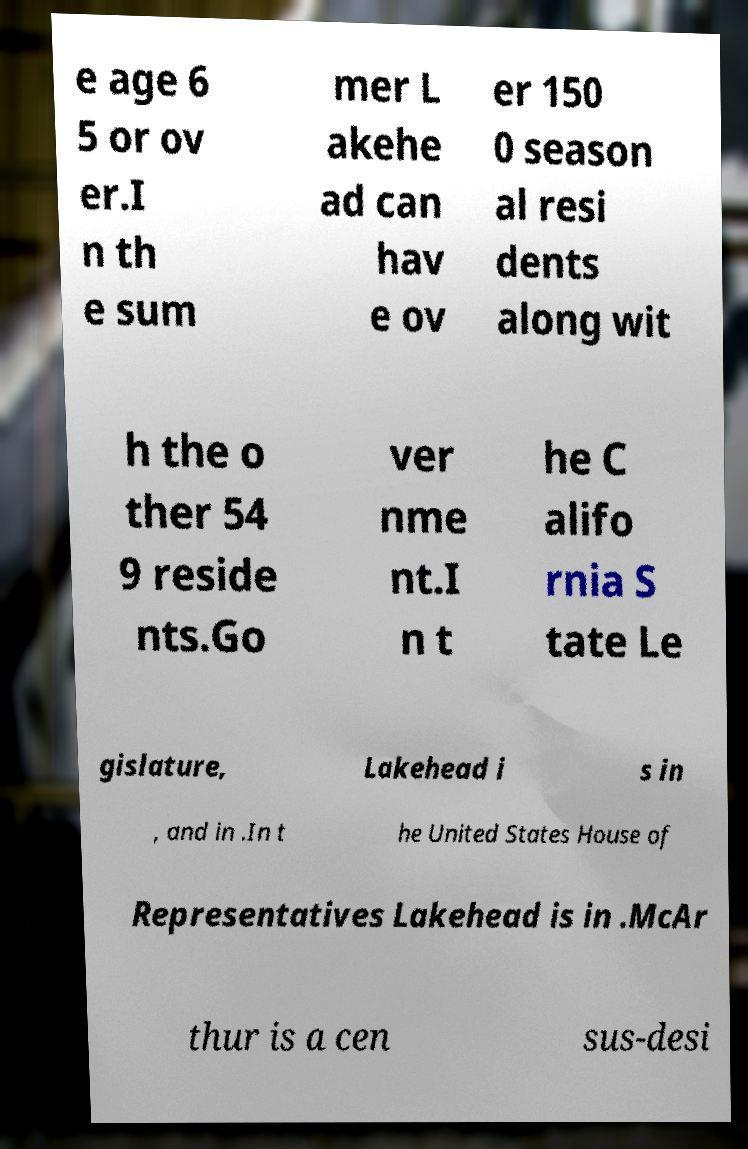Please identify and transcribe the text found in this image. e age 6 5 or ov er.I n th e sum mer L akehe ad can hav e ov er 150 0 season al resi dents along wit h the o ther 54 9 reside nts.Go ver nme nt.I n t he C alifo rnia S tate Le gislature, Lakehead i s in , and in .In t he United States House of Representatives Lakehead is in .McAr thur is a cen sus-desi 